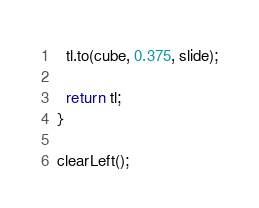Convert code to text. <code><loc_0><loc_0><loc_500><loc_500><_JavaScript_>  tl.to(cube, 0.375, slide);

  return tl;
}

clearLeft();</code> 